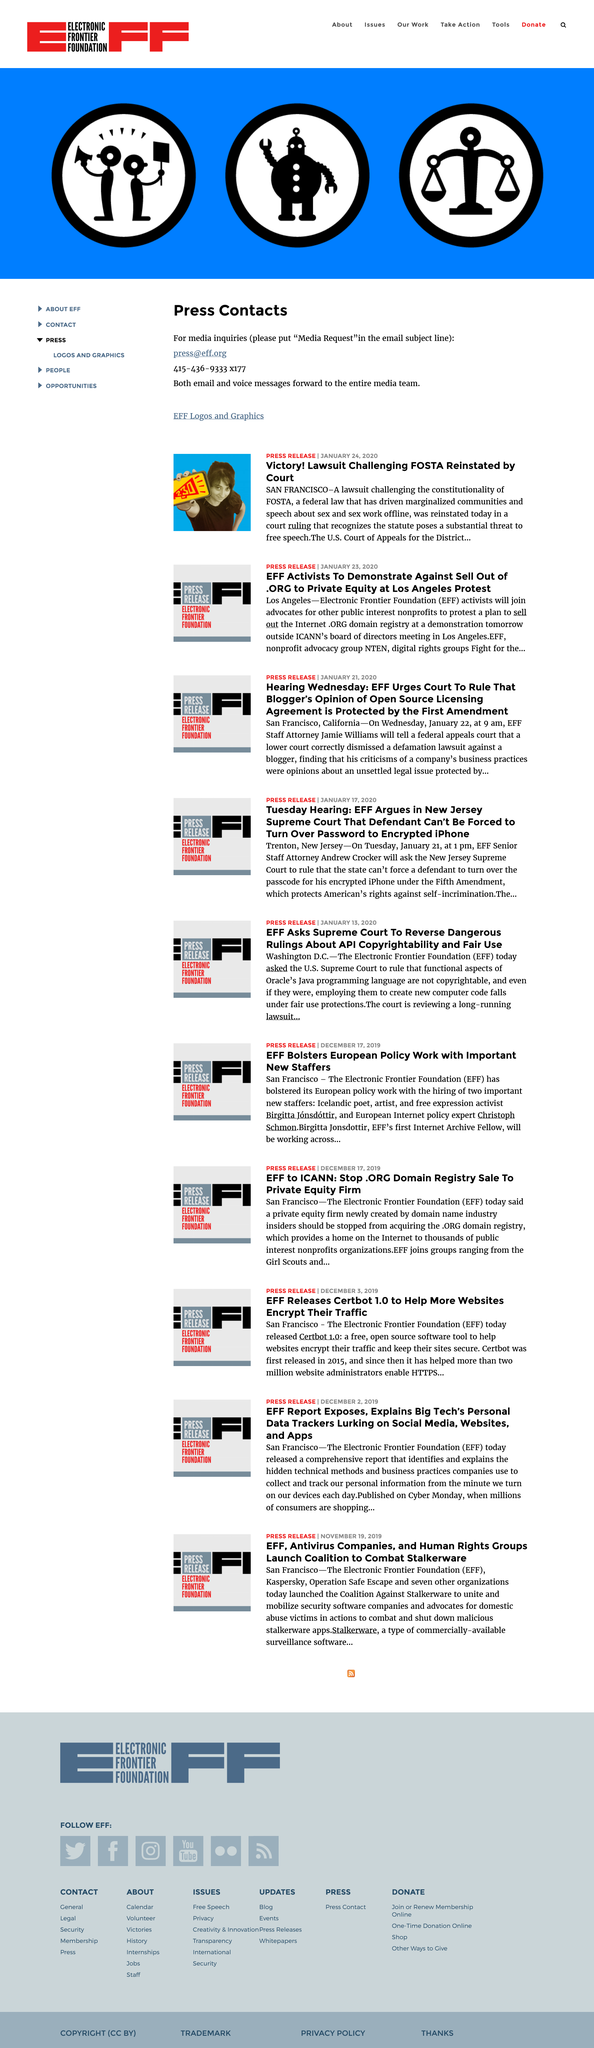List a handful of essential elements in this visual. The press release entitled 'Victory! Lawsuit Challenging FOSTA Reinstated by Court' was published on January 24, 2020. The Electronic Frontier Foundation, commonly referred to as EFF, is a non-profit organization that promotes civil liberties in the digital world. Jamie Williams is the EFF Staff Attorney. 